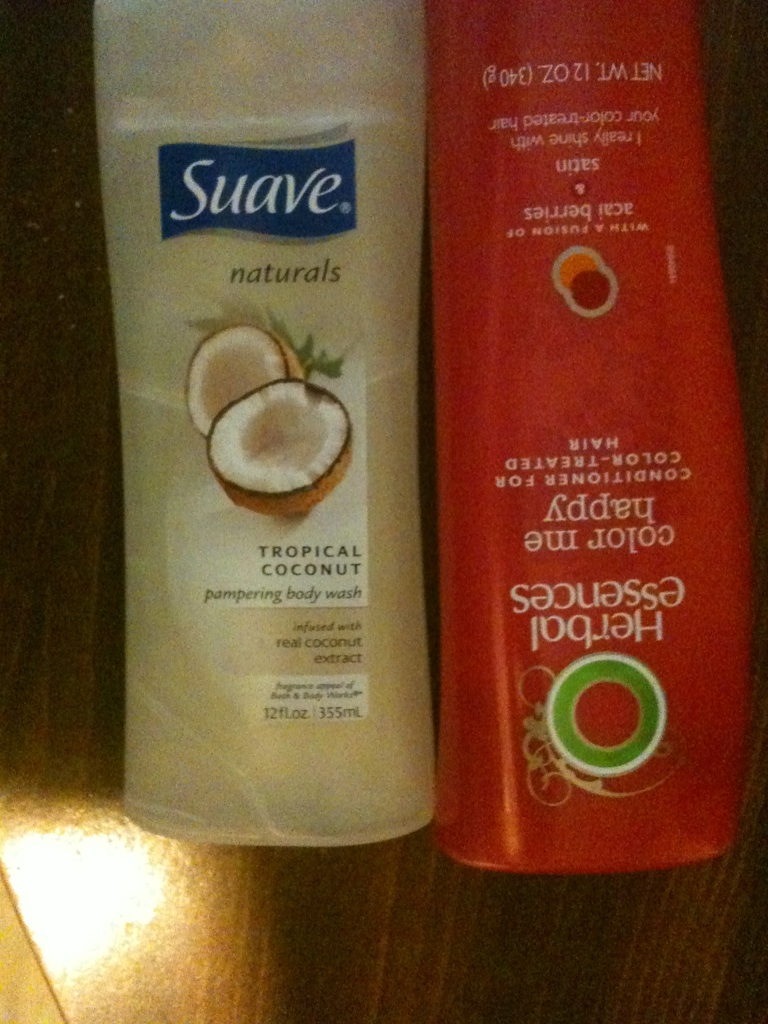What are some benefits of using these products? The Suave Tropical Coconut Pampering Body Wash offers benefits such as moisturizing your skin and providing a refreshing coconut scent. The Herbal Essences Color Me Happy Conditioner helps in maintaining color-treated hair, adding shine, and protecting the hair from damage. Do these products contain any special ingredients? Yes, the Suave Tropical Coconut Pampering Body Wash contains real coconut extract, which is known for its hydrating and nourishing properties. The Herbal Essences Color Me Happy Conditioner contains a blend of antioxidant-rich ingredients and moisturizing elements to protect and enhance the shine of color-treated hair. Can these products be used together in a regimen? Absolutely! Using Suave Tropical Coconut Pampering Body Wash followed by Herbal Essences Color Me Happy Conditioner can create a well-rounded regimen. Start with the body wash to cleanse and hydrate your skin, then use the conditioner to treat and protect your color-treated hair, leaving both your skin and hair feeling pampered and refreshed. 